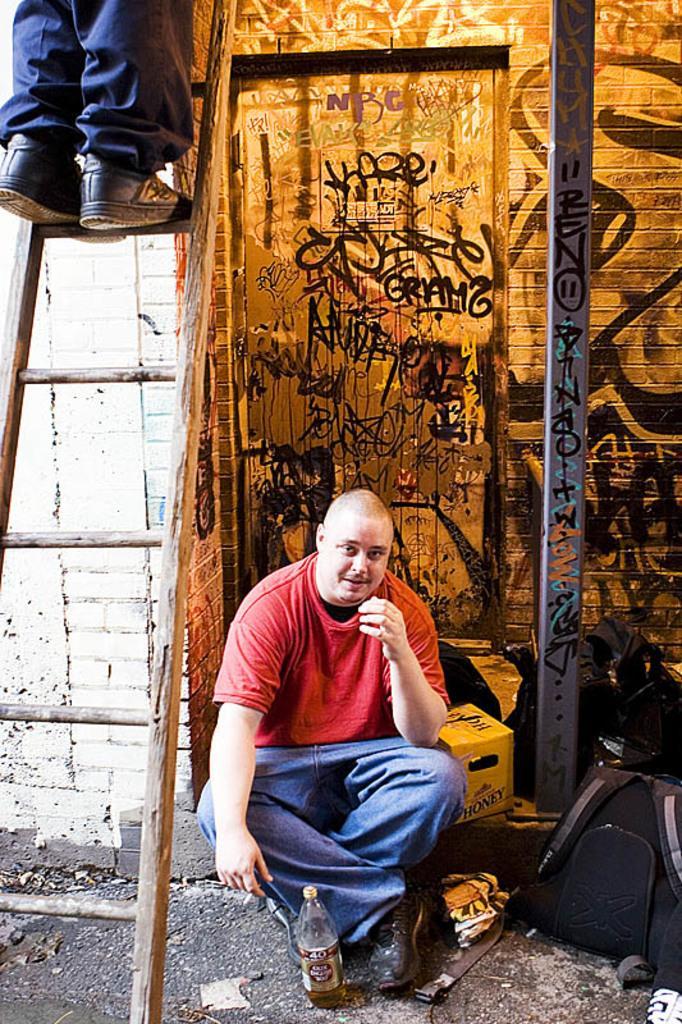Could you give a brief overview of what you see in this image? In the center we can see one person is sitting in front of him there is a water bottle. To the left side we can see the ladder and one person is standing on it. Coming to the background we can see the wall. And the right side we can see the backpack. 